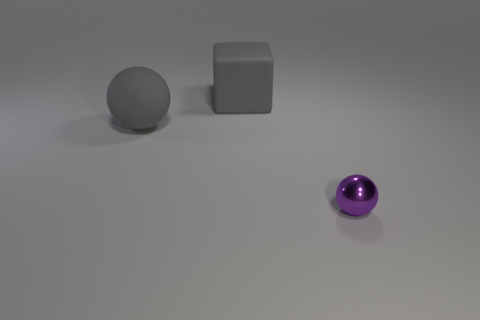Add 1 big gray rubber cubes. How many objects exist? 4 Subtract all balls. How many objects are left? 1 Subtract all small blue shiny spheres. Subtract all purple spheres. How many objects are left? 2 Add 3 gray things. How many gray things are left? 5 Add 3 matte balls. How many matte balls exist? 4 Subtract 1 gray blocks. How many objects are left? 2 